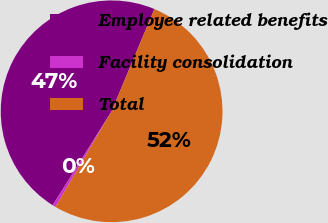Convert chart. <chart><loc_0><loc_0><loc_500><loc_500><pie_chart><fcel>Employee related benefits<fcel>Facility consolidation<fcel>Total<nl><fcel>47.4%<fcel>0.46%<fcel>52.14%<nl></chart> 